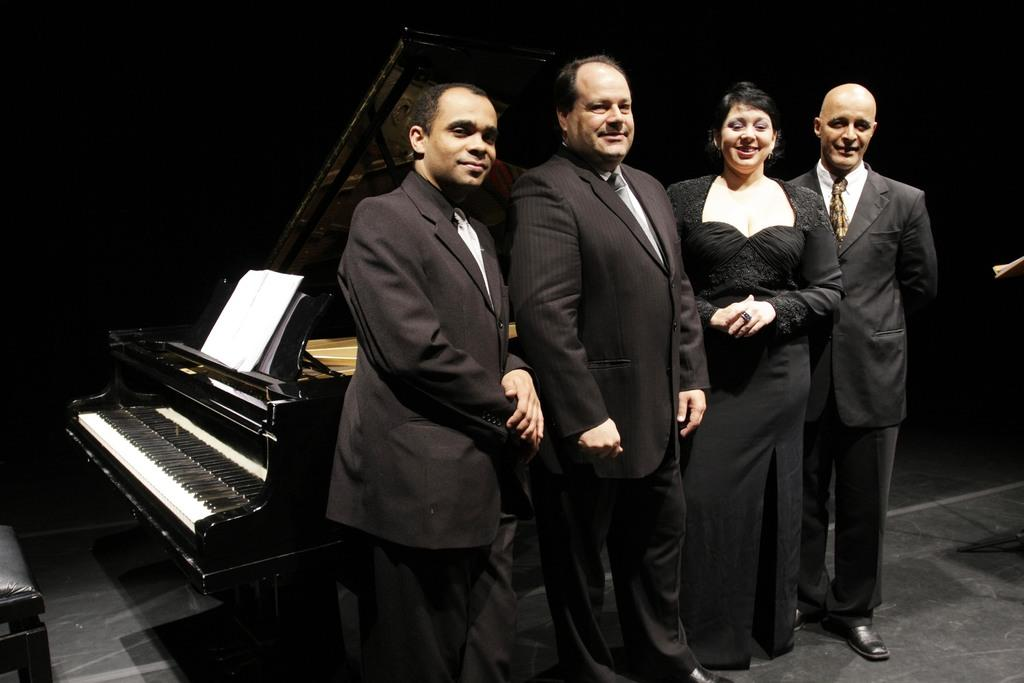How many people are present in the image? There are four people in the image: three men and one woman. What are the people in the image doing? The woman and men are standing. What can be seen in the background of the image? There is a piano and a paper in the background of the image. What type of clam is sitting on the bridge in the image? There is no clam or bridge present in the image. How many top hats can be seen on the people in the image? There is no mention of top hats in the image, so it cannot be determined how many are present. 